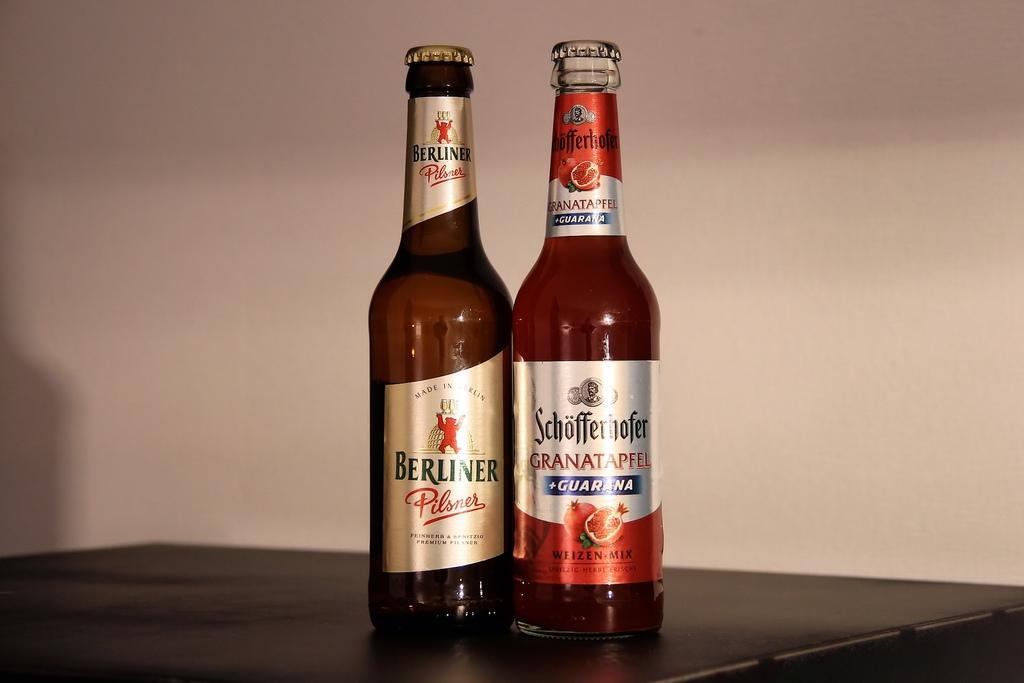How would you summarize this image in a sentence or two? In this picture the bottles are on the table. At the background there is wall. 